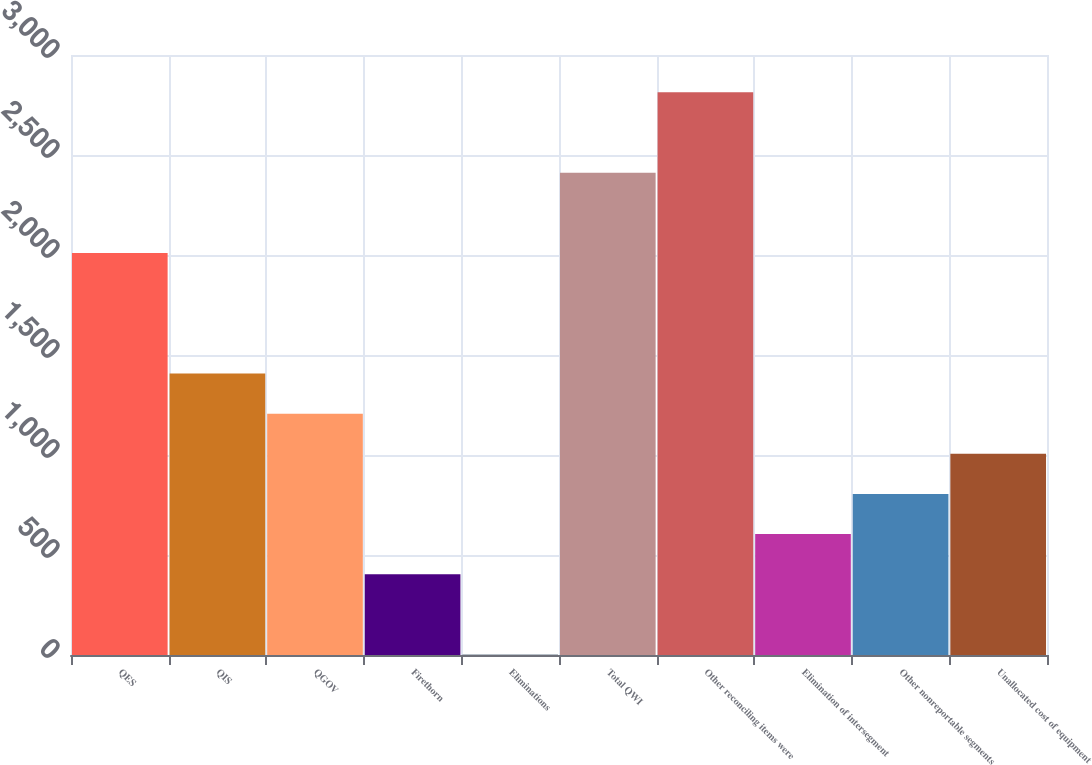Convert chart. <chart><loc_0><loc_0><loc_500><loc_500><bar_chart><fcel>QES<fcel>QIS<fcel>QGOV<fcel>Firethorn<fcel>Eliminations<fcel>Total QWI<fcel>Other reconciling items were<fcel>Elimination of intersegment<fcel>Other nonreportable segments<fcel>Unallocated cost of equipment<nl><fcel>2010<fcel>1407.6<fcel>1206.8<fcel>403.6<fcel>2<fcel>2411.6<fcel>2813.2<fcel>604.4<fcel>805.2<fcel>1006<nl></chart> 